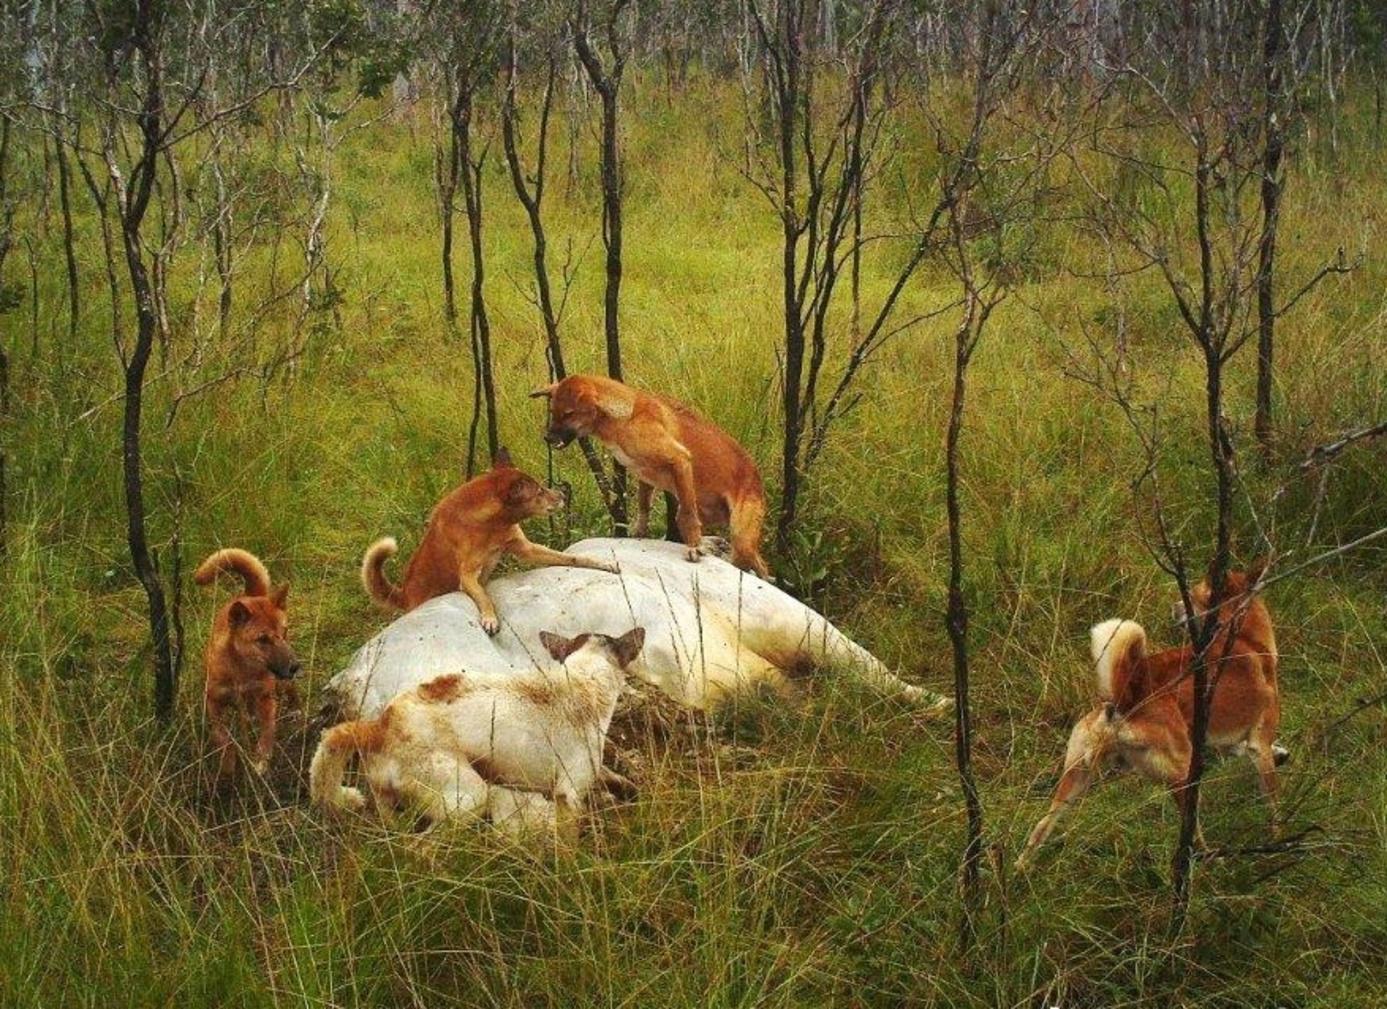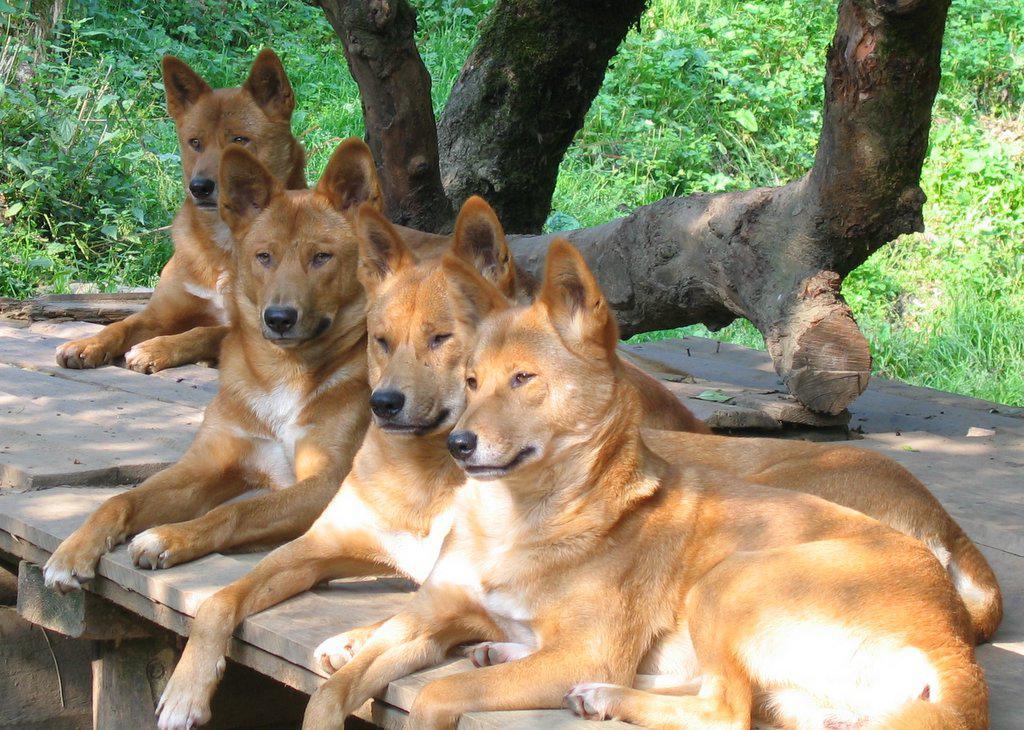The first image is the image on the left, the second image is the image on the right. Analyze the images presented: Is the assertion "An image shows multiple dogs reclining near some type of tree log." valid? Answer yes or no. Yes. 